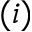Convert formula to latex. <formula><loc_0><loc_0><loc_500><loc_500>( i )</formula> 